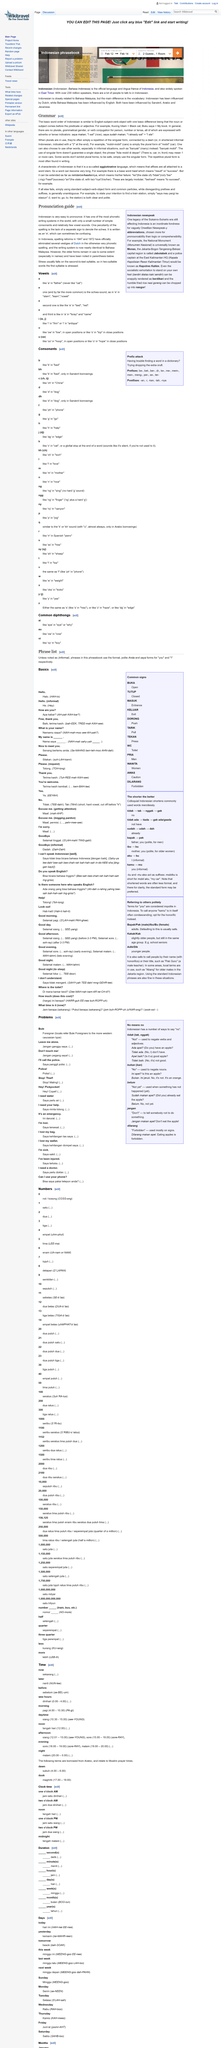Give some essential details in this illustration. In Indonesian, the schwa can cause confusion in spelling because it is often written as an "e," which can be different from the way it is pronounced. This can lead to errors in spelling and can make it difficult for people to correctly pronounce certain words. Yes, it is an element of Indonesian grammar that plurals are often a repetition of the singular form. The pronunciation guide claims that it is very easy to pronounce words in Indonesian due to their writing system being one of the most phonetic in the world. The repetitive plural form is most commonly found in written contexts. The use of singular form does not guarantee the existence of a single object. 